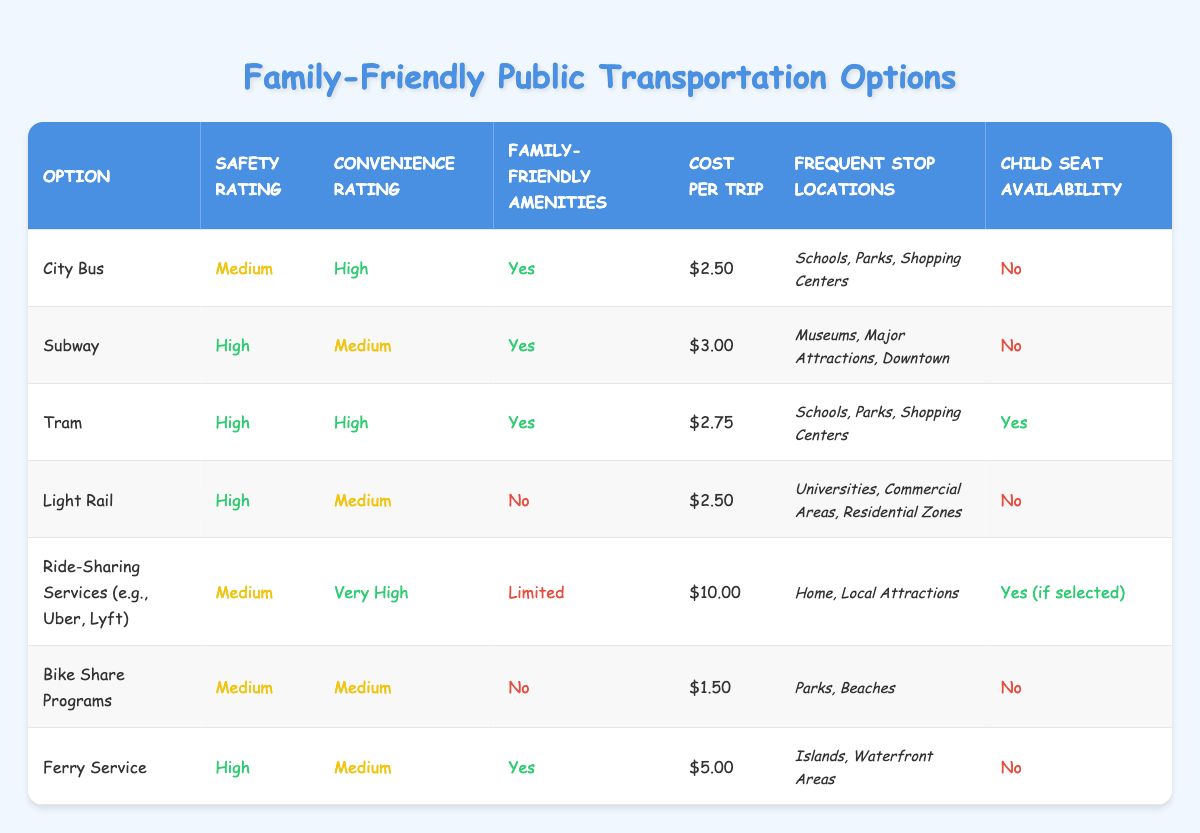What is the cost per trip for Tram? The cost per trip for Tram is listed in the table under the "Cost per Trip" column, where Tram is found. It shows $2.75.
Answer: $2.75 Which option has the highest safety rating? Looking at the "Safety Rating" column, both the Subway, Tram, Light Rail, and Ferry Service have a "High" safety rating. However, for the most comprehensive understanding, multiple options share this rating.
Answer: Subway, Tram, Light Rail, Ferry Service Does the City Bus have child seat availability? In the "Child Seat Availability" column for the City Bus, it is indicated as "No."
Answer: No What is the average cost per trip of all the options listed? Summing the costs ($2.50 + $3.00 + $2.75 + $2.50 + $10.00 + $1.50 + $5.00 = $27.25) and dividing by the number of options (7), we get the average cost: $27.25 / 7 = $3.89.
Answer: $3.89 Is there any option with family-friendly amenities that does not have child seat availability? In the "Family-Friendly Amenities" column, both the Subway and Ferry Service have "Yes," but in the "Child Seat Availability" column, both show "No." Thus, they are options meeting this criterion.
Answer: Yes, Subway and Ferry Service Which transportation option is the most convenient overall? The "Convenience Rating" is highest for Ride-Sharing Services with a "Very High" rating. Comparing convenience ratings shows this option stands out among others.
Answer: Ride-Sharing Services How many options have child seat availability? Reviewing the "Child Seat Availability" column, Tram shows "Yes," and Ride-Sharing Services shows "Yes (if selected)." Counting these gives a total of 2 options.
Answer: 2 What is the difference in cost per trip between the most and least expensive options? The highest cost per trip is for Ride-Sharing Services at $10.00, and the lowest is for Bike Share Programs at $1.50. Calculating the difference: $10.00 - $1.50 = $8.50.
Answer: $8.50 What are the frequent stop locations for the Light Rail? The "Frequent Stop Locations" column provides the specific stops for the Light Rail, which lists "Universities, Commercial Areas, Residential Zones."
Answer: Universities, Commercial Areas, Residential Zones 